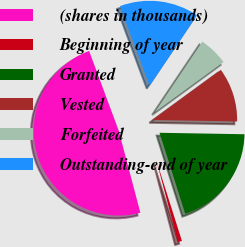Convert chart to OTSL. <chart><loc_0><loc_0><loc_500><loc_500><pie_chart><fcel>(shares in thousands)<fcel>Beginning of year<fcel>Granted<fcel>Vested<fcel>Forfeited<fcel>Outstanding-end of year<nl><fcel>48.44%<fcel>0.78%<fcel>19.84%<fcel>10.31%<fcel>5.55%<fcel>15.08%<nl></chart> 